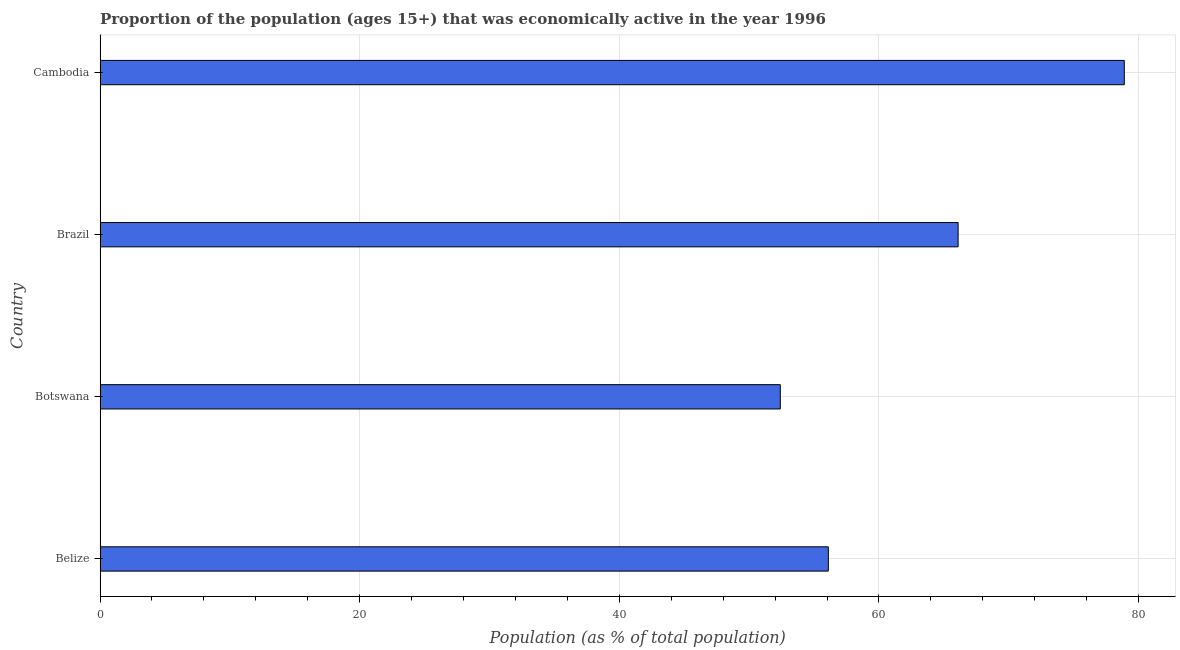Does the graph contain any zero values?
Keep it short and to the point. No. What is the title of the graph?
Your response must be concise. Proportion of the population (ages 15+) that was economically active in the year 1996. What is the label or title of the X-axis?
Ensure brevity in your answer.  Population (as % of total population). What is the percentage of economically active population in Botswana?
Make the answer very short. 52.4. Across all countries, what is the maximum percentage of economically active population?
Ensure brevity in your answer.  78.9. Across all countries, what is the minimum percentage of economically active population?
Offer a very short reply. 52.4. In which country was the percentage of economically active population maximum?
Provide a succinct answer. Cambodia. In which country was the percentage of economically active population minimum?
Your answer should be compact. Botswana. What is the sum of the percentage of economically active population?
Provide a short and direct response. 253.5. What is the difference between the percentage of economically active population in Belize and Cambodia?
Your response must be concise. -22.8. What is the average percentage of economically active population per country?
Provide a short and direct response. 63.38. What is the median percentage of economically active population?
Make the answer very short. 61.1. In how many countries, is the percentage of economically active population greater than 56 %?
Offer a terse response. 3. What is the ratio of the percentage of economically active population in Belize to that in Brazil?
Your answer should be compact. 0.85. What is the difference between the highest and the second highest percentage of economically active population?
Provide a short and direct response. 12.8. Is the sum of the percentage of economically active population in Brazil and Cambodia greater than the maximum percentage of economically active population across all countries?
Keep it short and to the point. Yes. In how many countries, is the percentage of economically active population greater than the average percentage of economically active population taken over all countries?
Keep it short and to the point. 2. How many countries are there in the graph?
Your answer should be compact. 4. What is the difference between two consecutive major ticks on the X-axis?
Your response must be concise. 20. Are the values on the major ticks of X-axis written in scientific E-notation?
Your response must be concise. No. What is the Population (as % of total population) in Belize?
Your answer should be compact. 56.1. What is the Population (as % of total population) of Botswana?
Ensure brevity in your answer.  52.4. What is the Population (as % of total population) of Brazil?
Provide a short and direct response. 66.1. What is the Population (as % of total population) of Cambodia?
Provide a short and direct response. 78.9. What is the difference between the Population (as % of total population) in Belize and Botswana?
Give a very brief answer. 3.7. What is the difference between the Population (as % of total population) in Belize and Cambodia?
Offer a very short reply. -22.8. What is the difference between the Population (as % of total population) in Botswana and Brazil?
Your response must be concise. -13.7. What is the difference between the Population (as % of total population) in Botswana and Cambodia?
Offer a very short reply. -26.5. What is the ratio of the Population (as % of total population) in Belize to that in Botswana?
Your response must be concise. 1.07. What is the ratio of the Population (as % of total population) in Belize to that in Brazil?
Ensure brevity in your answer.  0.85. What is the ratio of the Population (as % of total population) in Belize to that in Cambodia?
Offer a terse response. 0.71. What is the ratio of the Population (as % of total population) in Botswana to that in Brazil?
Offer a terse response. 0.79. What is the ratio of the Population (as % of total population) in Botswana to that in Cambodia?
Provide a short and direct response. 0.66. What is the ratio of the Population (as % of total population) in Brazil to that in Cambodia?
Offer a very short reply. 0.84. 